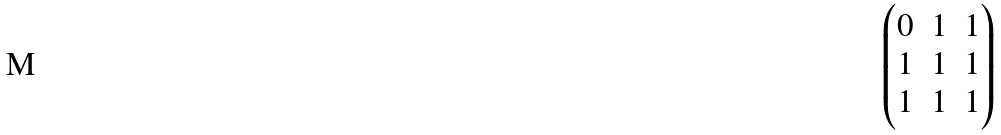<formula> <loc_0><loc_0><loc_500><loc_500>\begin{pmatrix} 0 & 1 & 1 \\ 1 & 1 & 1 \\ 1 & 1 & 1 \end{pmatrix}</formula> 